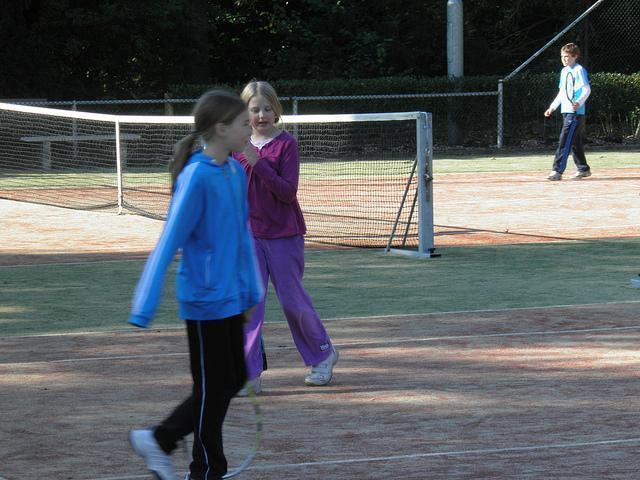What hair style does the girl in blue have?
From the following set of four choices, select the accurate answer to respond to the question.
Options: Pig tails, mullet, pony tail, crew cut. Pony tail. 